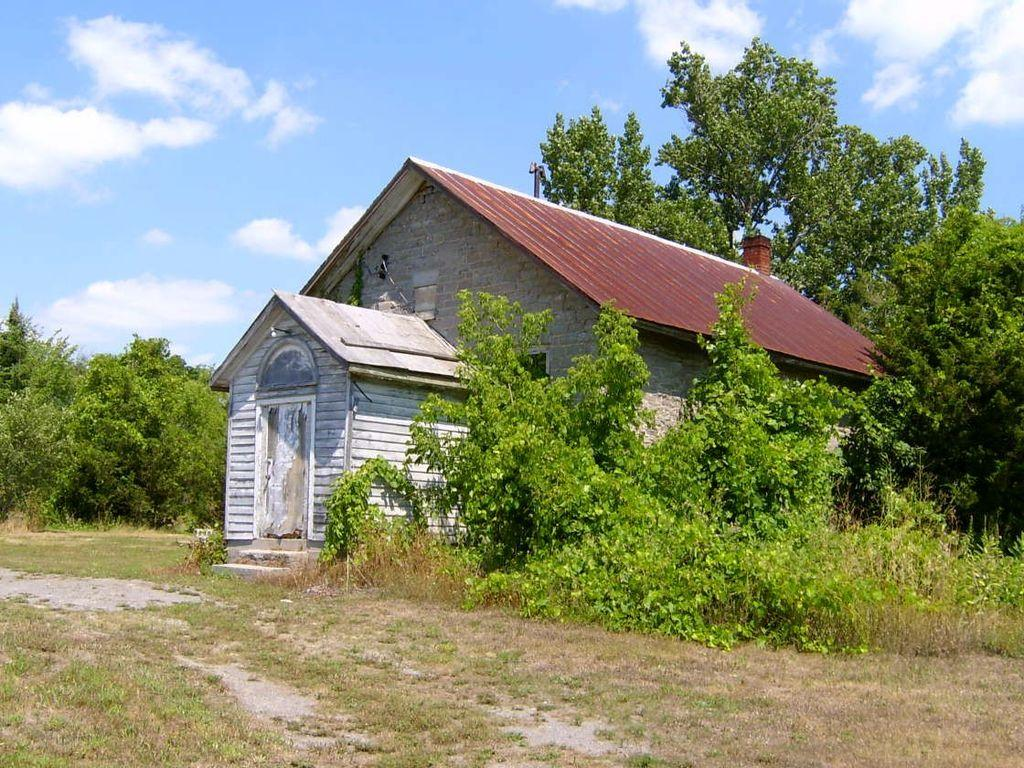What is the setting of the image? The image is an outside view. What is the main structure in the image? There is a house in the middle of the image. What type of vegetation surrounds the house? There are many plants and trees around the house. What can be seen at the top of the image? The sky is visible at the top of the image, and clouds are present in the sky. What type of spark can be seen coming from the dad's mind in the image? There is no dad or spark present in the image; it is an outside view of a house surrounded by plants and trees. 